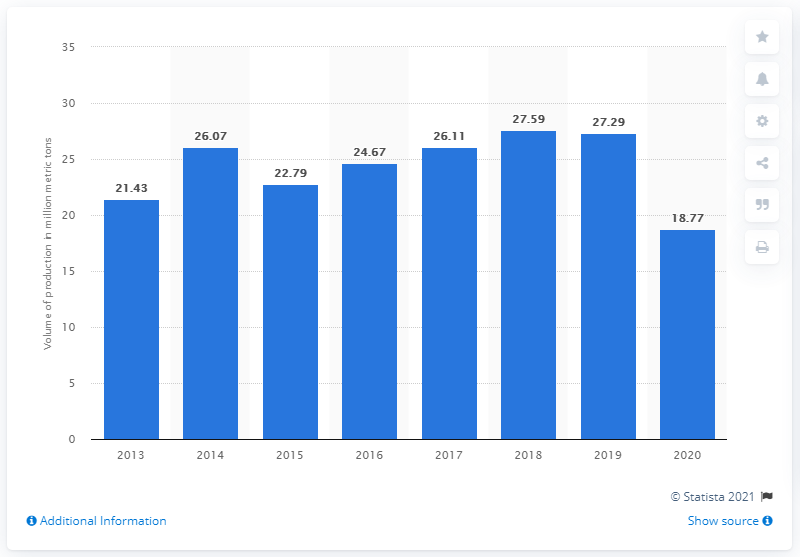Draw attention to some important aspects in this diagram. In 2020, Consol Energy produced 18.77 tons of coal. 